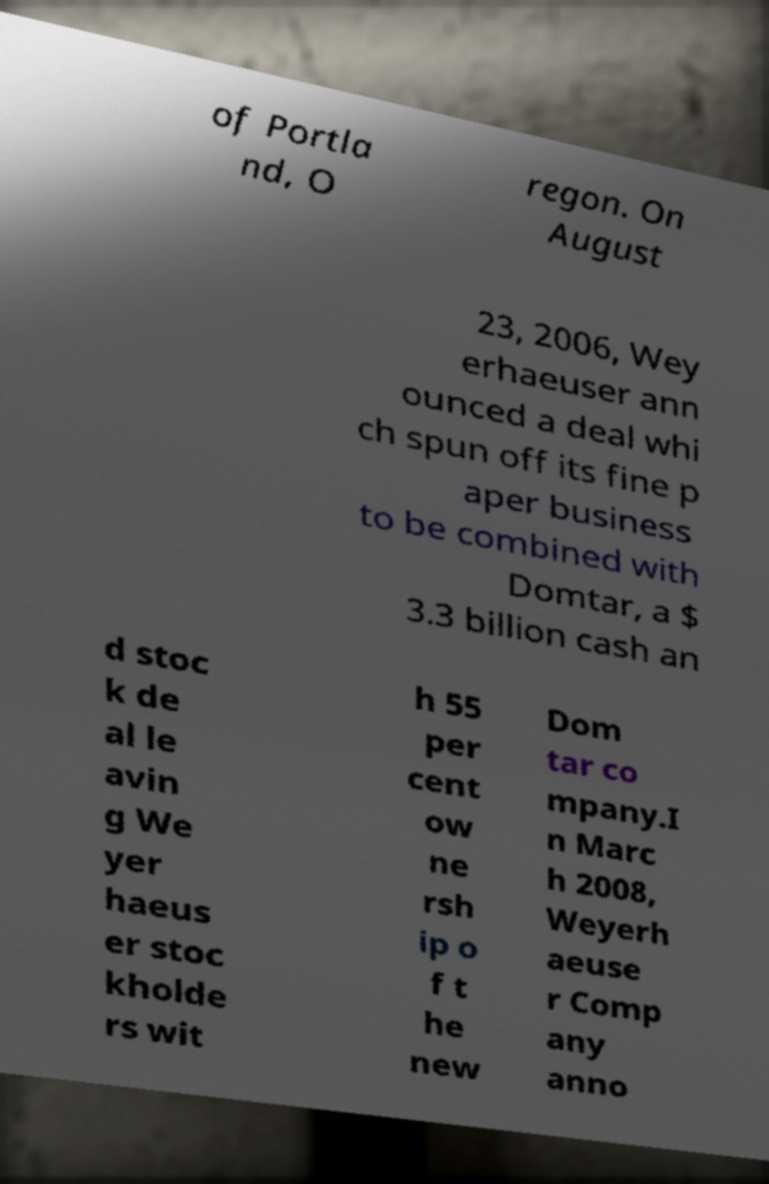Can you read and provide the text displayed in the image?This photo seems to have some interesting text. Can you extract and type it out for me? of Portla nd, O regon. On August 23, 2006, Wey erhaeuser ann ounced a deal whi ch spun off its fine p aper business to be combined with Domtar, a $ 3.3 billion cash an d stoc k de al le avin g We yer haeus er stoc kholde rs wit h 55 per cent ow ne rsh ip o f t he new Dom tar co mpany.I n Marc h 2008, Weyerh aeuse r Comp any anno 